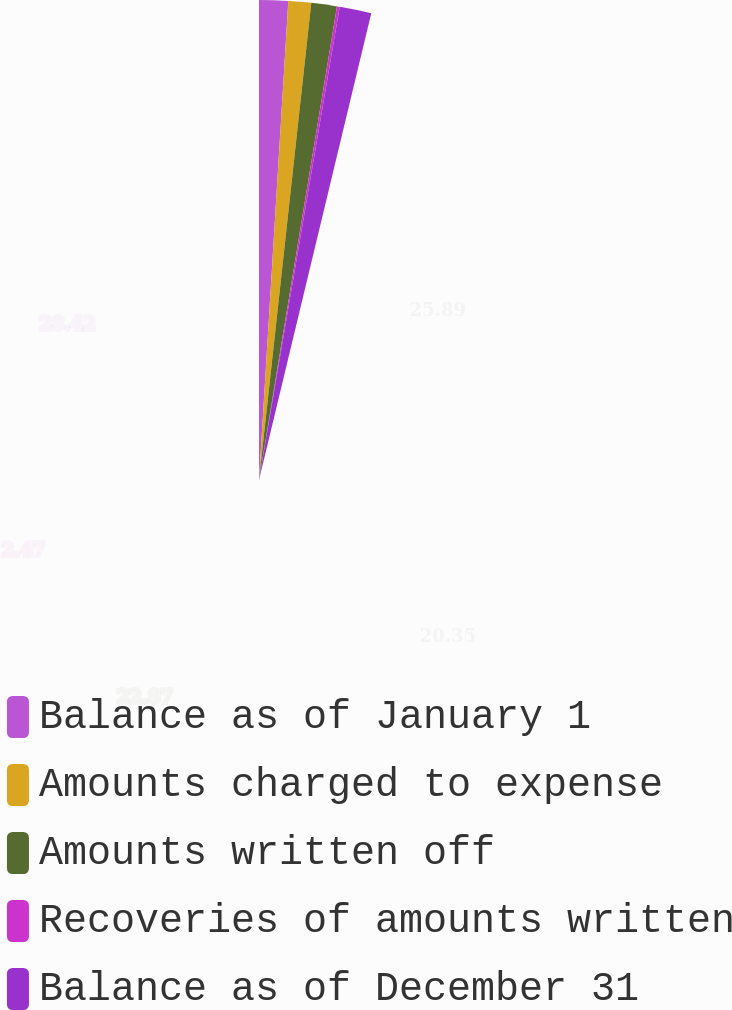Convert chart to OTSL. <chart><loc_0><loc_0><loc_500><loc_500><pie_chart><fcel>Balance as of January 1<fcel>Amounts charged to expense<fcel>Amounts written off<fcel>Recoveries of amounts written<fcel>Balance as of December 31<nl><fcel>25.89%<fcel>20.35%<fcel>22.87%<fcel>2.47%<fcel>28.42%<nl></chart> 